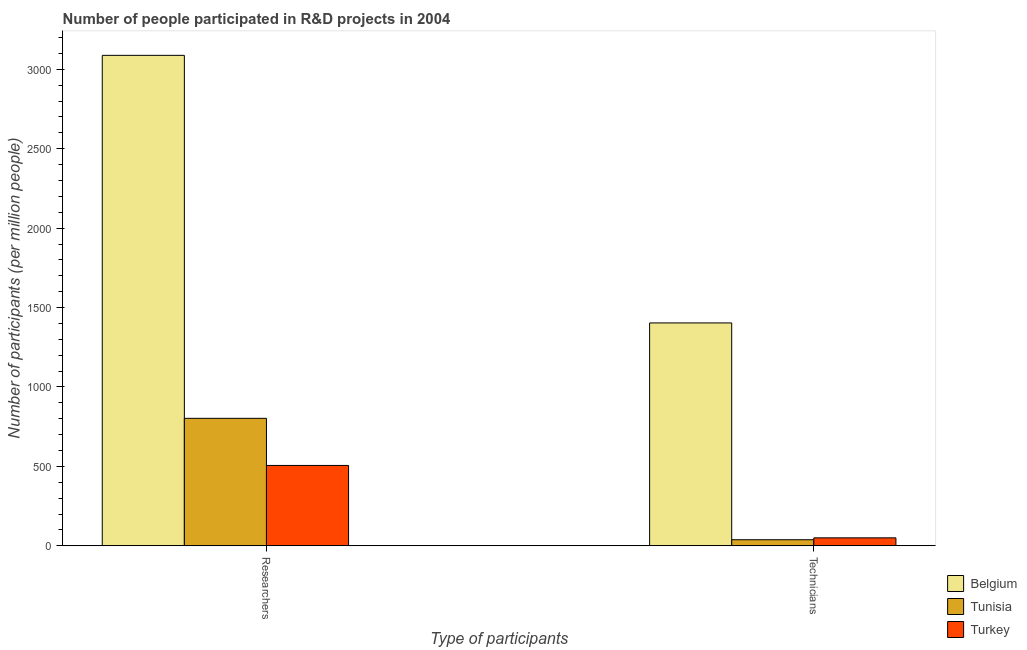Are the number of bars on each tick of the X-axis equal?
Make the answer very short. Yes. How many bars are there on the 1st tick from the right?
Provide a short and direct response. 3. What is the label of the 1st group of bars from the left?
Offer a very short reply. Researchers. What is the number of researchers in Tunisia?
Keep it short and to the point. 802.4. Across all countries, what is the maximum number of researchers?
Offer a very short reply. 3087.91. Across all countries, what is the minimum number of researchers?
Offer a very short reply. 505.82. In which country was the number of researchers maximum?
Your response must be concise. Belgium. In which country was the number of researchers minimum?
Offer a very short reply. Turkey. What is the total number of researchers in the graph?
Provide a short and direct response. 4396.13. What is the difference between the number of technicians in Belgium and that in Tunisia?
Keep it short and to the point. 1365.02. What is the difference between the number of technicians in Belgium and the number of researchers in Tunisia?
Your response must be concise. 600.72. What is the average number of researchers per country?
Your answer should be compact. 1465.38. What is the difference between the number of technicians and number of researchers in Tunisia?
Your answer should be very brief. -764.3. In how many countries, is the number of researchers greater than 2500 ?
Your answer should be very brief. 1. What is the ratio of the number of technicians in Tunisia to that in Belgium?
Provide a short and direct response. 0.03. What does the 1st bar from the left in Researchers represents?
Your answer should be compact. Belgium. What does the 1st bar from the right in Technicians represents?
Your answer should be compact. Turkey. Are all the bars in the graph horizontal?
Ensure brevity in your answer.  No. How many countries are there in the graph?
Offer a terse response. 3. Does the graph contain any zero values?
Your answer should be very brief. No. Where does the legend appear in the graph?
Provide a succinct answer. Bottom right. How many legend labels are there?
Your response must be concise. 3. What is the title of the graph?
Offer a very short reply. Number of people participated in R&D projects in 2004. Does "Other small states" appear as one of the legend labels in the graph?
Ensure brevity in your answer.  No. What is the label or title of the X-axis?
Your answer should be very brief. Type of participants. What is the label or title of the Y-axis?
Give a very brief answer. Number of participants (per million people). What is the Number of participants (per million people) of Belgium in Researchers?
Your answer should be compact. 3087.91. What is the Number of participants (per million people) of Tunisia in Researchers?
Offer a terse response. 802.4. What is the Number of participants (per million people) in Turkey in Researchers?
Your answer should be compact. 505.82. What is the Number of participants (per million people) of Belgium in Technicians?
Make the answer very short. 1403.12. What is the Number of participants (per million people) in Tunisia in Technicians?
Your answer should be compact. 38.1. What is the Number of participants (per million people) in Turkey in Technicians?
Your response must be concise. 49.89. Across all Type of participants, what is the maximum Number of participants (per million people) in Belgium?
Provide a succinct answer. 3087.91. Across all Type of participants, what is the maximum Number of participants (per million people) of Tunisia?
Your answer should be very brief. 802.4. Across all Type of participants, what is the maximum Number of participants (per million people) of Turkey?
Ensure brevity in your answer.  505.82. Across all Type of participants, what is the minimum Number of participants (per million people) of Belgium?
Offer a terse response. 1403.12. Across all Type of participants, what is the minimum Number of participants (per million people) of Tunisia?
Your answer should be very brief. 38.1. Across all Type of participants, what is the minimum Number of participants (per million people) of Turkey?
Offer a terse response. 49.89. What is the total Number of participants (per million people) in Belgium in the graph?
Your response must be concise. 4491.03. What is the total Number of participants (per million people) in Tunisia in the graph?
Provide a short and direct response. 840.5. What is the total Number of participants (per million people) of Turkey in the graph?
Offer a very short reply. 555.71. What is the difference between the Number of participants (per million people) of Belgium in Researchers and that in Technicians?
Offer a very short reply. 1684.8. What is the difference between the Number of participants (per million people) in Tunisia in Researchers and that in Technicians?
Make the answer very short. 764.3. What is the difference between the Number of participants (per million people) of Turkey in Researchers and that in Technicians?
Offer a terse response. 455.93. What is the difference between the Number of participants (per million people) of Belgium in Researchers and the Number of participants (per million people) of Tunisia in Technicians?
Your response must be concise. 3049.81. What is the difference between the Number of participants (per million people) in Belgium in Researchers and the Number of participants (per million people) in Turkey in Technicians?
Offer a terse response. 3038.02. What is the difference between the Number of participants (per million people) of Tunisia in Researchers and the Number of participants (per million people) of Turkey in Technicians?
Keep it short and to the point. 752.51. What is the average Number of participants (per million people) in Belgium per Type of participants?
Your response must be concise. 2245.52. What is the average Number of participants (per million people) of Tunisia per Type of participants?
Keep it short and to the point. 420.25. What is the average Number of participants (per million people) in Turkey per Type of participants?
Offer a terse response. 277.85. What is the difference between the Number of participants (per million people) of Belgium and Number of participants (per million people) of Tunisia in Researchers?
Make the answer very short. 2285.51. What is the difference between the Number of participants (per million people) in Belgium and Number of participants (per million people) in Turkey in Researchers?
Your answer should be very brief. 2582.09. What is the difference between the Number of participants (per million people) in Tunisia and Number of participants (per million people) in Turkey in Researchers?
Your answer should be very brief. 296.58. What is the difference between the Number of participants (per million people) of Belgium and Number of participants (per million people) of Tunisia in Technicians?
Provide a short and direct response. 1365.02. What is the difference between the Number of participants (per million people) of Belgium and Number of participants (per million people) of Turkey in Technicians?
Give a very brief answer. 1353.23. What is the difference between the Number of participants (per million people) of Tunisia and Number of participants (per million people) of Turkey in Technicians?
Provide a short and direct response. -11.79. What is the ratio of the Number of participants (per million people) in Belgium in Researchers to that in Technicians?
Provide a succinct answer. 2.2. What is the ratio of the Number of participants (per million people) in Tunisia in Researchers to that in Technicians?
Offer a very short reply. 21.06. What is the ratio of the Number of participants (per million people) of Turkey in Researchers to that in Technicians?
Ensure brevity in your answer.  10.14. What is the difference between the highest and the second highest Number of participants (per million people) of Belgium?
Offer a terse response. 1684.8. What is the difference between the highest and the second highest Number of participants (per million people) in Tunisia?
Your response must be concise. 764.3. What is the difference between the highest and the second highest Number of participants (per million people) in Turkey?
Offer a very short reply. 455.93. What is the difference between the highest and the lowest Number of participants (per million people) of Belgium?
Offer a very short reply. 1684.8. What is the difference between the highest and the lowest Number of participants (per million people) of Tunisia?
Offer a very short reply. 764.3. What is the difference between the highest and the lowest Number of participants (per million people) of Turkey?
Your answer should be compact. 455.93. 